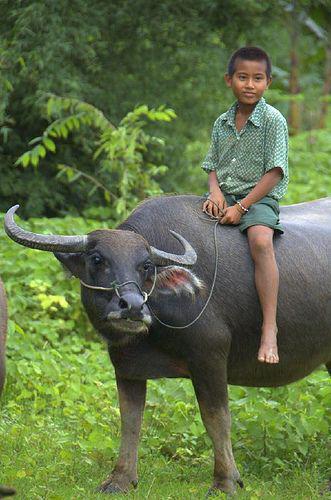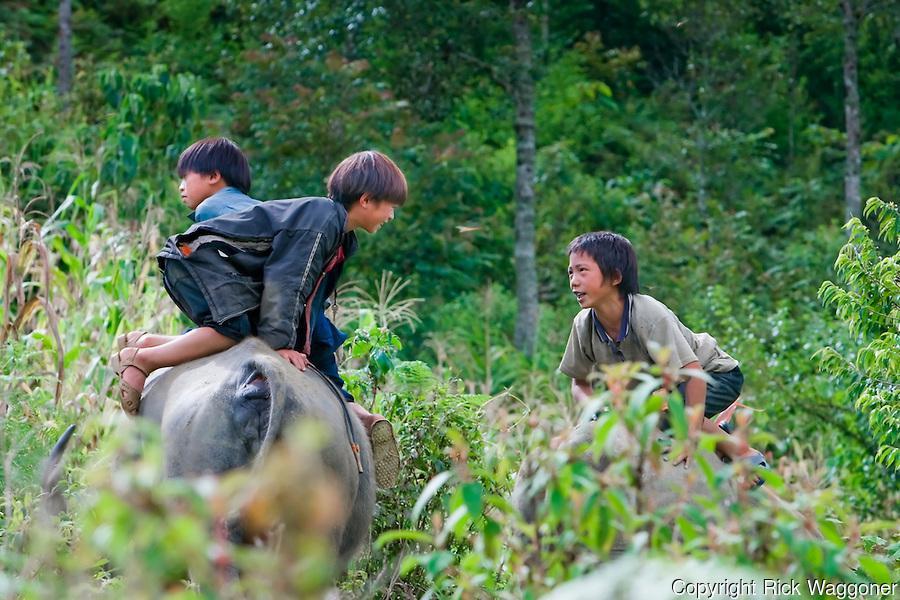The first image is the image on the left, the second image is the image on the right. Examine the images to the left and right. Is the description "Each image features a young boy on top of a water buffalo's back, but only the left image shows a boy sitting with his legs dangling over the sides of the animal." accurate? Answer yes or no. Yes. The first image is the image on the left, the second image is the image on the right. Evaluate the accuracy of this statement regarding the images: "A small boy straddles a horned cow in the image on the left.". Is it true? Answer yes or no. Yes. 